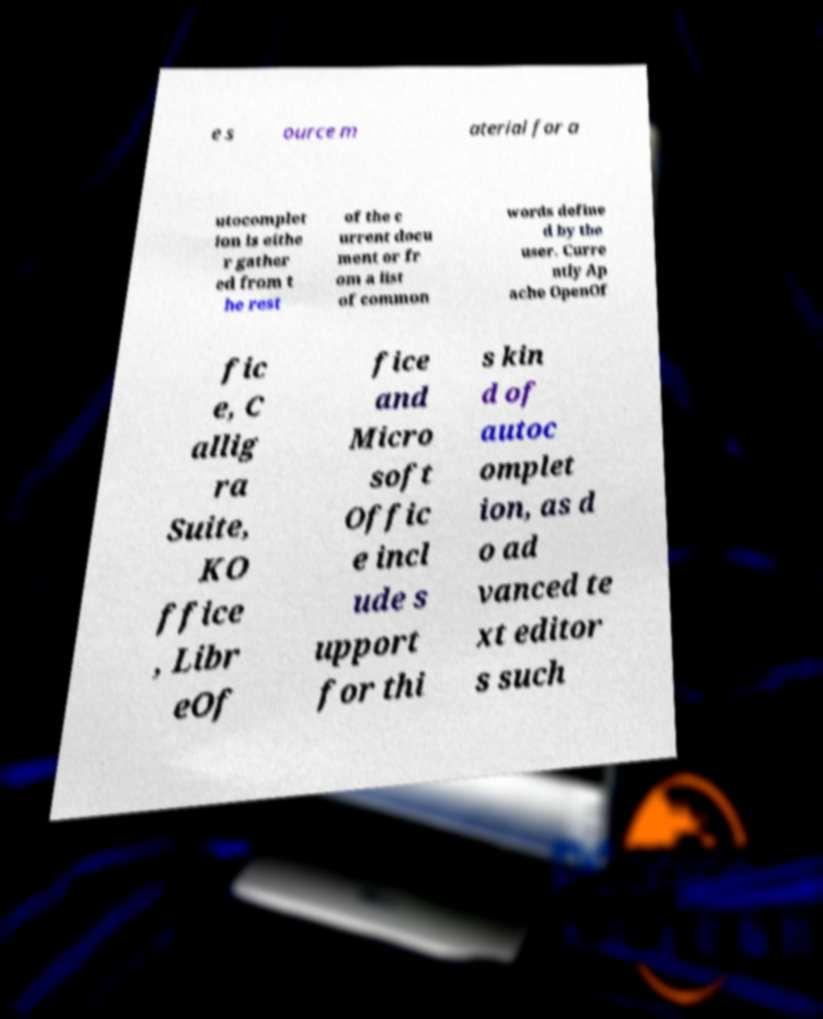There's text embedded in this image that I need extracted. Can you transcribe it verbatim? e s ource m aterial for a utocomplet ion is eithe r gather ed from t he rest of the c urrent docu ment or fr om a list of common words define d by the user. Curre ntly Ap ache OpenOf fic e, C allig ra Suite, KO ffice , Libr eOf fice and Micro soft Offic e incl ude s upport for thi s kin d of autoc omplet ion, as d o ad vanced te xt editor s such 